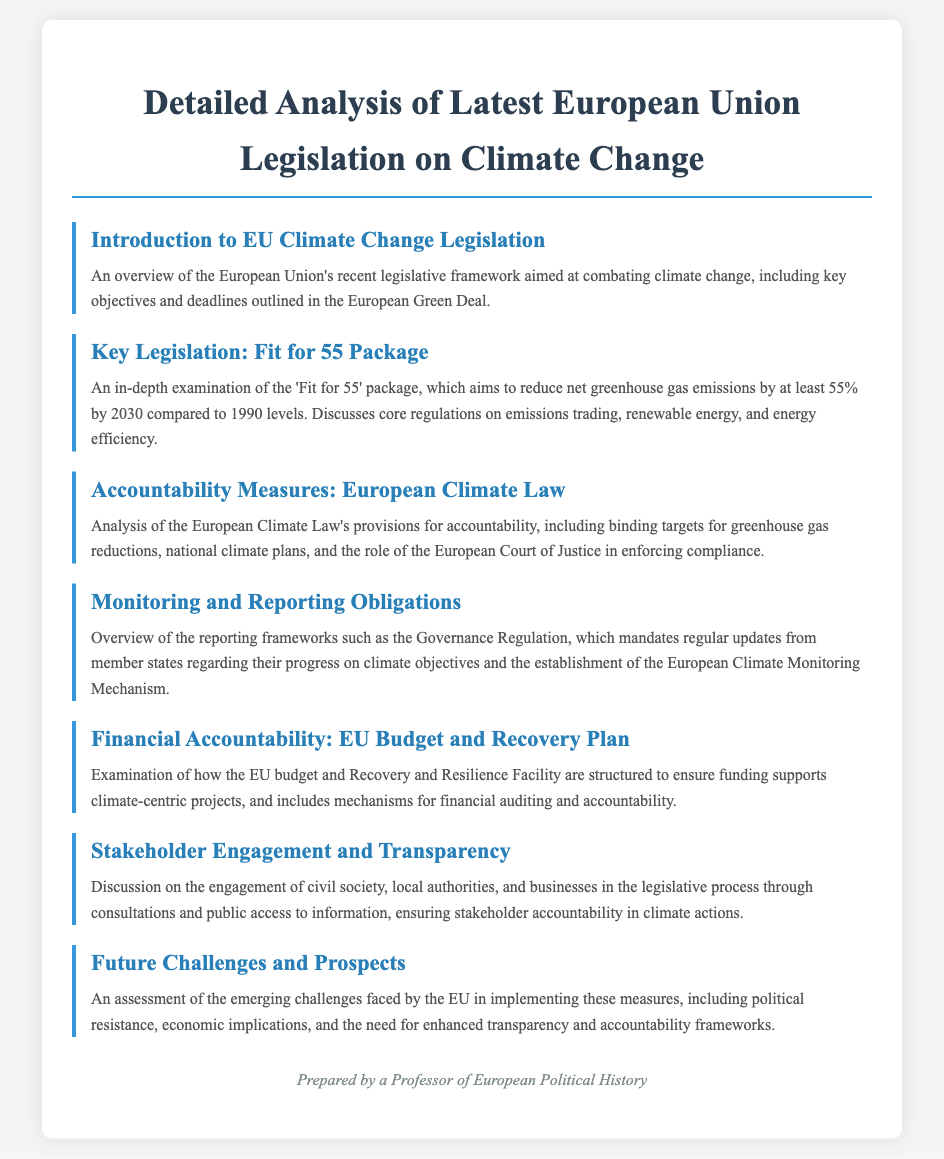What is the name of the package aiming for a 55% reduction in emissions? The package is specifically referred to as the 'Fit for 55' package, which targets a reduction in net greenhouse gas emissions.
Answer: 'Fit for 55' package What is the European Climate Law's primary purpose? The primary purpose of the European Climate Law is to establish binding targets for greenhouse gas reductions.
Answer: Binding targets What does the Governance Regulation mandate? The Governance Regulation mandates regular updates from member states regarding their progress on climate objectives.
Answer: Regular updates Which facility supports financial accountability for climate projects? The Recovery and Resilience Facility is mentioned as a mechanism to ensure funding for climate-centric projects.
Answer: Recovery and Resilience Facility What is a key challenge mentioned for the EU regarding climate measures? A key challenge mentioned is political resistance to implementing the climate measures effectively.
Answer: Political resistance How are stakeholders engaged in the legislative process? Stakeholder engagement occurs through consultations and public access to information.
Answer: Consultations and public access What is the title of the document? The title of the document is "Detailed Analysis of Latest European Union Legislation on Climate Change."
Answer: Detailed Analysis of Latest European Union Legislation on Climate Change What role does the European Court of Justice play in the Climate Law? The European Court of Justice is involved in enforcing compliance with the provisions of the Climate Law.
Answer: Enforcing compliance 